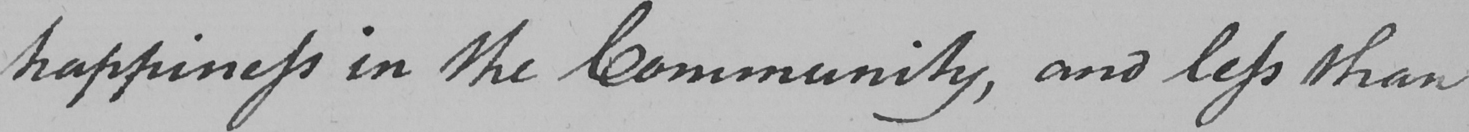What text is written in this handwritten line? -happiness in the Community , and less than 